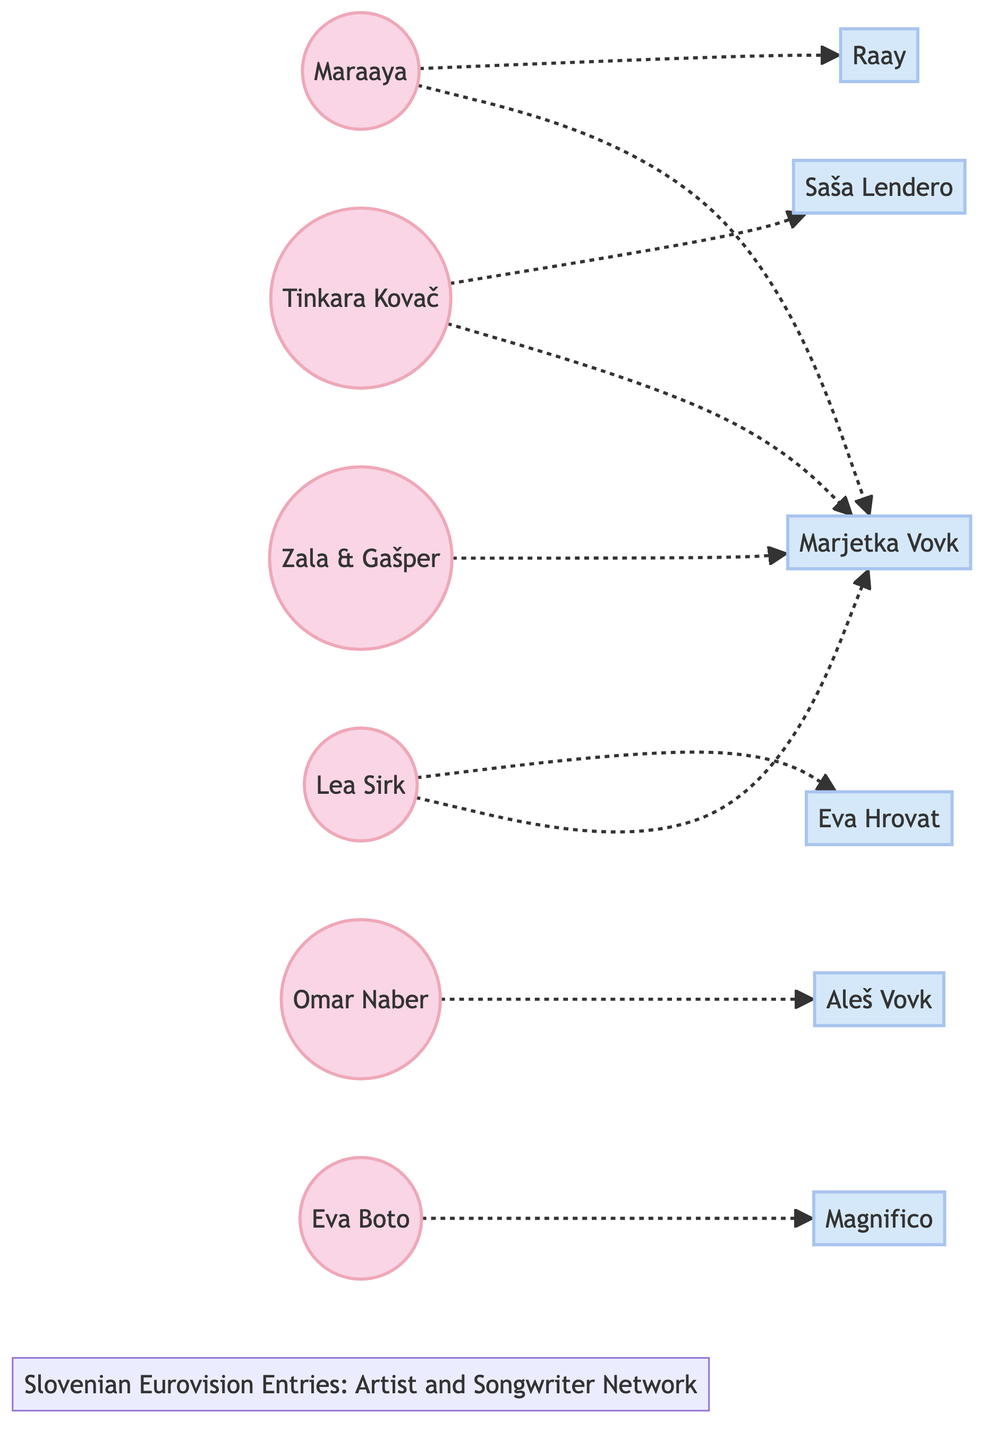What is the total number of artists in the diagram? Counting the nodes labeled as "Artist", we have Tinkara Kovač, Maraaya, Omar Naber, Zala & Gašper, Eva Boto, and Lea Sirk. This gives a total of 6 artists.
Answer: 6 Which songwriter collaborated with Tinkara Kovač? Looking at the connections (edges) from the node Tinkara Kovač, there are two edges: one to Saša Lendero and one to Marjetka Vovk. Therefore, the songwriters are Saša Lendero and Marjetka Vovk.
Answer: Saša Lendero, Marjetka Vovk How many edges are present in the diagram? To find the number of edges, we can count each line connecting the nodes. There are 8 edges in total, indicating collaborations between the artists and songwriters.
Answer: 8 Which artist collaborated with Marjetka Vovk? A review of the edges tells us that Maraaya, Zala & Gašper, and Lea Sirk collaborated with Marjetka Vovk. Hence, the artists are Maraaya, Zala & Gašper, and Lea Sirk.
Answer: Maraaya, Zala & Gašper, Lea Sirk Which songwriter has the most collaborations? By examining the edges, Marjetka Vovk appears multiple times as she collaborates with three different artists: Tinkara Kovač, Maraaya, and Zala & Gašper, indicating she has the most collaborations.
Answer: Marjetka Vovk What is the unique label of the node connected to Omar Naber? The edge connecting to Omar Naber points to Aleš Vovk, indicating that this songwriter collaborated with him. Thus, the unique label is Aleš Vovk.
Answer: Aleš Vovk 